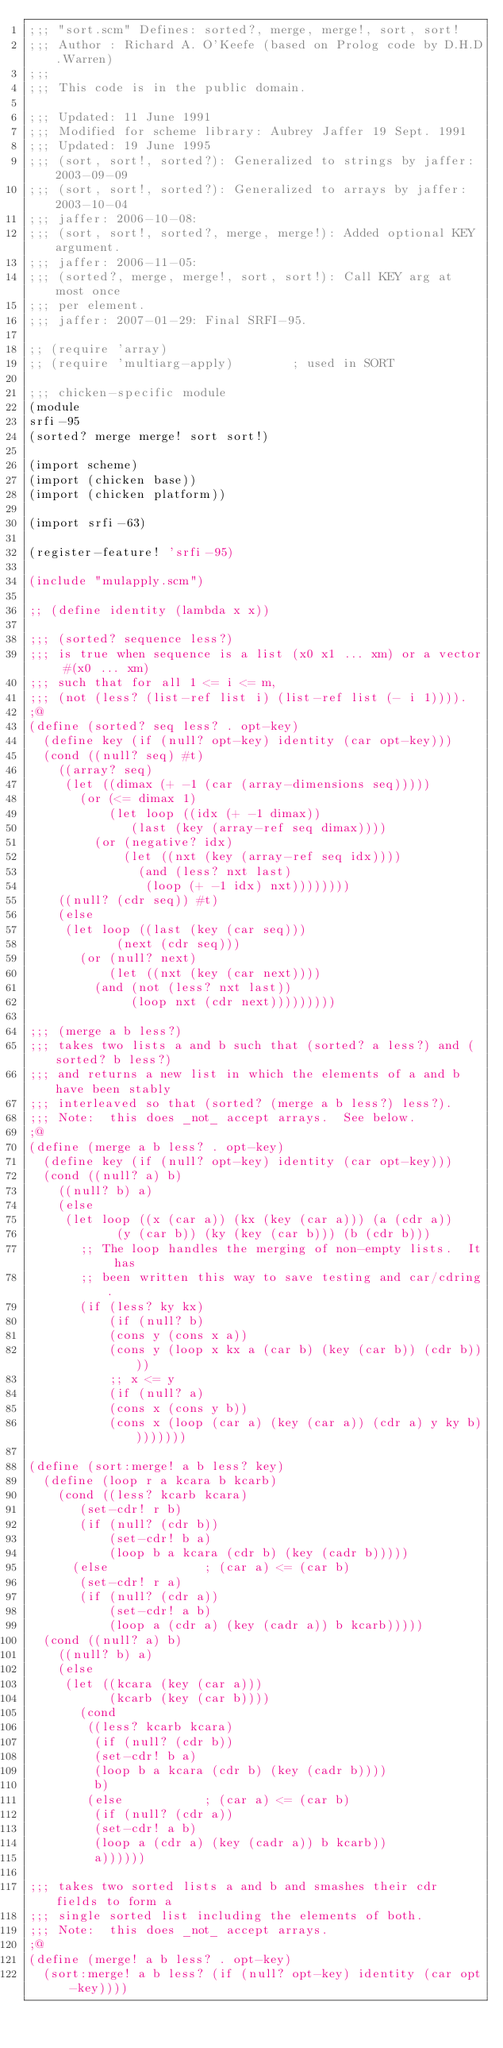<code> <loc_0><loc_0><loc_500><loc_500><_Scheme_>;;; "sort.scm" Defines: sorted?, merge, merge!, sort, sort!
;;; Author : Richard A. O'Keefe (based on Prolog code by D.H.D.Warren)
;;;
;;; This code is in the public domain.

;;; Updated: 11 June 1991
;;; Modified for scheme library: Aubrey Jaffer 19 Sept. 1991
;;; Updated: 19 June 1995
;;; (sort, sort!, sorted?): Generalized to strings by jaffer: 2003-09-09
;;; (sort, sort!, sorted?): Generalized to arrays by jaffer: 2003-10-04
;;; jaffer: 2006-10-08:
;;; (sort, sort!, sorted?, merge, merge!): Added optional KEY argument.
;;; jaffer: 2006-11-05:
;;; (sorted?, merge, merge!, sort, sort!): Call KEY arg at most once
;;; per element.
;;; jaffer: 2007-01-29: Final SRFI-95.

;; (require 'array)
;; (require 'multiarg-apply)		; used in SORT

;;; chicken-specific module
(module
srfi-95
(sorted? merge merge! sort sort!)

(import scheme)
(import (chicken base))
(import (chicken platform))

(import srfi-63)

(register-feature! 'srfi-95)

(include "mulapply.scm")

;; (define identity (lambda x x))

;;; (sorted? sequence less?)
;;; is true when sequence is a list (x0 x1 ... xm) or a vector #(x0 ... xm)
;;; such that for all 1 <= i <= m,
;;;	(not (less? (list-ref list i) (list-ref list (- i 1)))).
;@
(define (sorted? seq less? . opt-key)
  (define key (if (null? opt-key) identity (car opt-key)))
  (cond ((null? seq) #t)
	((array? seq)
	 (let ((dimax (+ -1 (car (array-dimensions seq)))))
	   (or (<= dimax 1)
	       (let loop ((idx (+ -1 dimax))
			  (last (key (array-ref seq dimax))))
		 (or (negative? idx)
		     (let ((nxt (key (array-ref seq idx))))
		       (and (less? nxt last)
			    (loop (+ -1 idx) nxt))))))))
	((null? (cdr seq)) #t)
	(else
	 (let loop ((last (key (car seq)))
		    (next (cdr seq)))
	   (or (null? next)
	       (let ((nxt (key (car next))))
		 (and (not (less? nxt last))
		      (loop nxt (cdr next)))))))))

;;; (merge a b less?)
;;; takes two lists a and b such that (sorted? a less?) and (sorted? b less?)
;;; and returns a new list in which the elements of a and b have been stably
;;; interleaved so that (sorted? (merge a b less?) less?).
;;; Note:  this does _not_ accept arrays.  See below.
;@
(define (merge a b less? . opt-key)
  (define key (if (null? opt-key) identity (car opt-key)))
  (cond ((null? a) b)
	((null? b) a)
	(else
	 (let loop ((x (car a)) (kx (key (car a))) (a (cdr a))
		    (y (car b)) (ky (key (car b))) (b (cdr b)))
	   ;; The loop handles the merging of non-empty lists.  It has
	   ;; been written this way to save testing and car/cdring.
	   (if (less? ky kx)
	       (if (null? b)
		   (cons y (cons x a))
		   (cons y (loop x kx a (car b) (key (car b)) (cdr b))))
	       ;; x <= y
	       (if (null? a)
		   (cons x (cons y b))
		   (cons x (loop (car a) (key (car a)) (cdr a) y ky b))))))))

(define (sort:merge! a b less? key)
  (define (loop r a kcara b kcarb)
    (cond ((less? kcarb kcara)
	   (set-cdr! r b)
	   (if (null? (cdr b))
	       (set-cdr! b a)
	       (loop b a kcara (cdr b) (key (cadr b)))))
	  (else				; (car a) <= (car b)
	   (set-cdr! r a)
	   (if (null? (cdr a))
	       (set-cdr! a b)
	       (loop a (cdr a) (key (cadr a)) b kcarb)))))
  (cond ((null? a) b)
	((null? b) a)
	(else
	 (let ((kcara (key (car a)))
	       (kcarb (key (car b))))
	   (cond
	    ((less? kcarb kcara)
	     (if (null? (cdr b))
		 (set-cdr! b a)
		 (loop b a kcara (cdr b) (key (cadr b))))
	     b)
	    (else			; (car a) <= (car b)
	     (if (null? (cdr a))
		 (set-cdr! a b)
		 (loop a (cdr a) (key (cadr a)) b kcarb))
	     a))))))

;;; takes two sorted lists a and b and smashes their cdr fields to form a
;;; single sorted list including the elements of both.
;;; Note:  this does _not_ accept arrays.
;@
(define (merge! a b less? . opt-key)
  (sort:merge! a b less? (if (null? opt-key) identity (car opt-key))))
</code> 